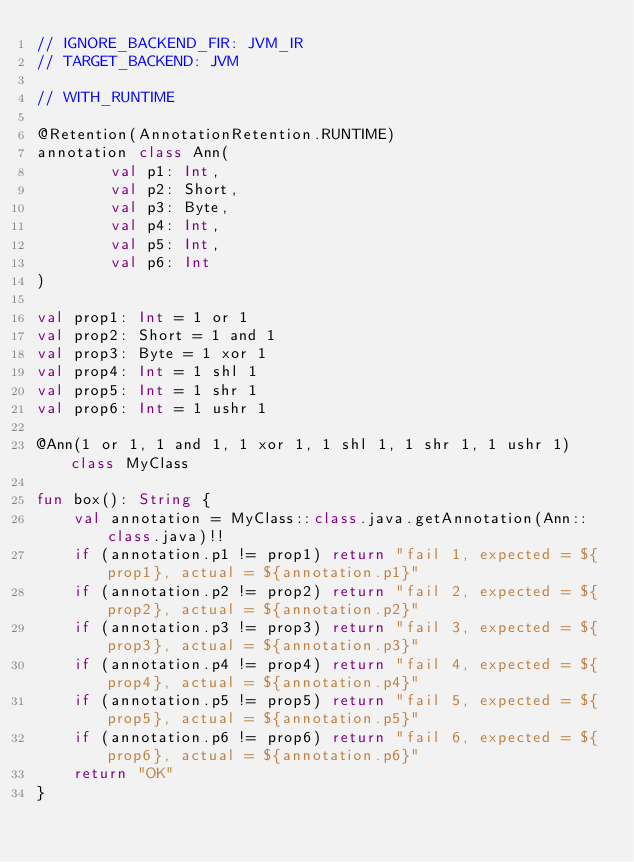Convert code to text. <code><loc_0><loc_0><loc_500><loc_500><_Kotlin_>// IGNORE_BACKEND_FIR: JVM_IR
// TARGET_BACKEND: JVM

// WITH_RUNTIME

@Retention(AnnotationRetention.RUNTIME)
annotation class Ann(
        val p1: Int,
        val p2: Short,
        val p3: Byte,
        val p4: Int,
        val p5: Int,
        val p6: Int
)

val prop1: Int = 1 or 1
val prop2: Short = 1 and 1
val prop3: Byte = 1 xor 1
val prop4: Int = 1 shl 1
val prop5: Int = 1 shr 1
val prop6: Int = 1 ushr 1

@Ann(1 or 1, 1 and 1, 1 xor 1, 1 shl 1, 1 shr 1, 1 ushr 1) class MyClass

fun box(): String {
    val annotation = MyClass::class.java.getAnnotation(Ann::class.java)!!
    if (annotation.p1 != prop1) return "fail 1, expected = ${prop1}, actual = ${annotation.p1}"
    if (annotation.p2 != prop2) return "fail 2, expected = ${prop2}, actual = ${annotation.p2}"
    if (annotation.p3 != prop3) return "fail 3, expected = ${prop3}, actual = ${annotation.p3}"
    if (annotation.p4 != prop4) return "fail 4, expected = ${prop4}, actual = ${annotation.p4}"
    if (annotation.p5 != prop5) return "fail 5, expected = ${prop5}, actual = ${annotation.p5}"
    if (annotation.p6 != prop6) return "fail 6, expected = ${prop6}, actual = ${annotation.p6}"
    return "OK"
}
</code> 